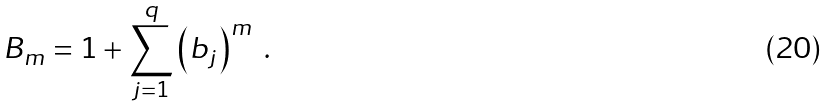<formula> <loc_0><loc_0><loc_500><loc_500>B _ { m } = 1 + \sum _ { j = 1 } ^ { q } \left ( b _ { j } \right ) ^ { m } \ .</formula> 